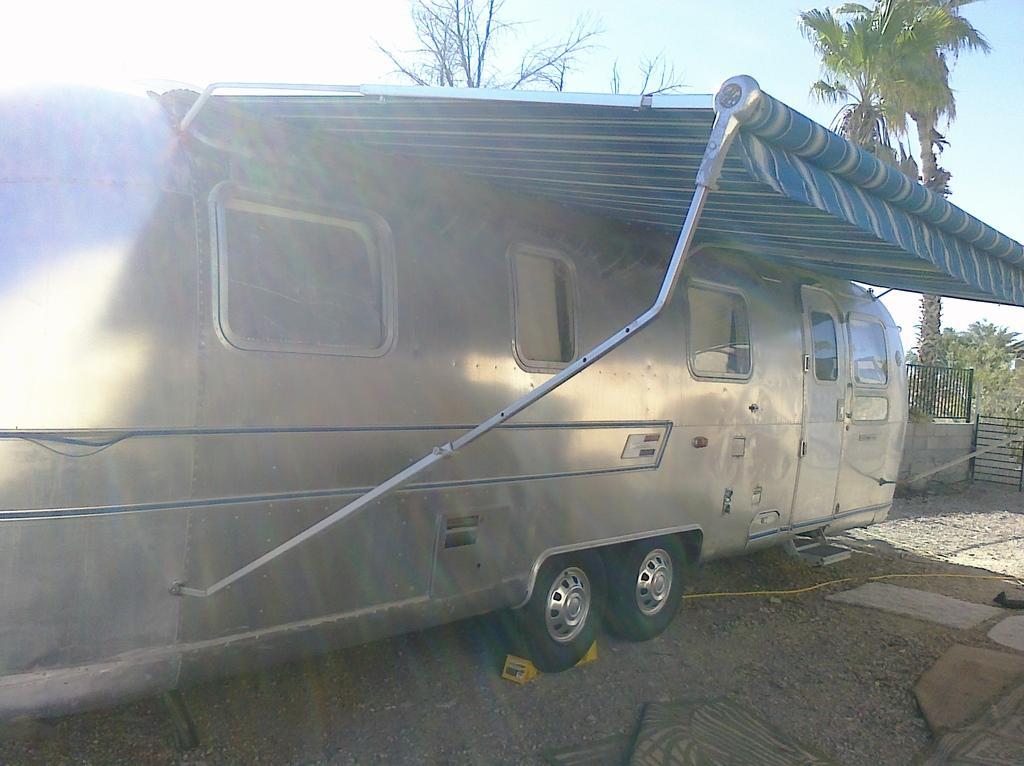Describe this image in one or two sentences. This image is taken outdoors. At the bottom of the image there is a ground. In the background there are a few trees and a wall with railing. At the top of the image there is a sky. In the middle of the image there is a van parked on the ground. 